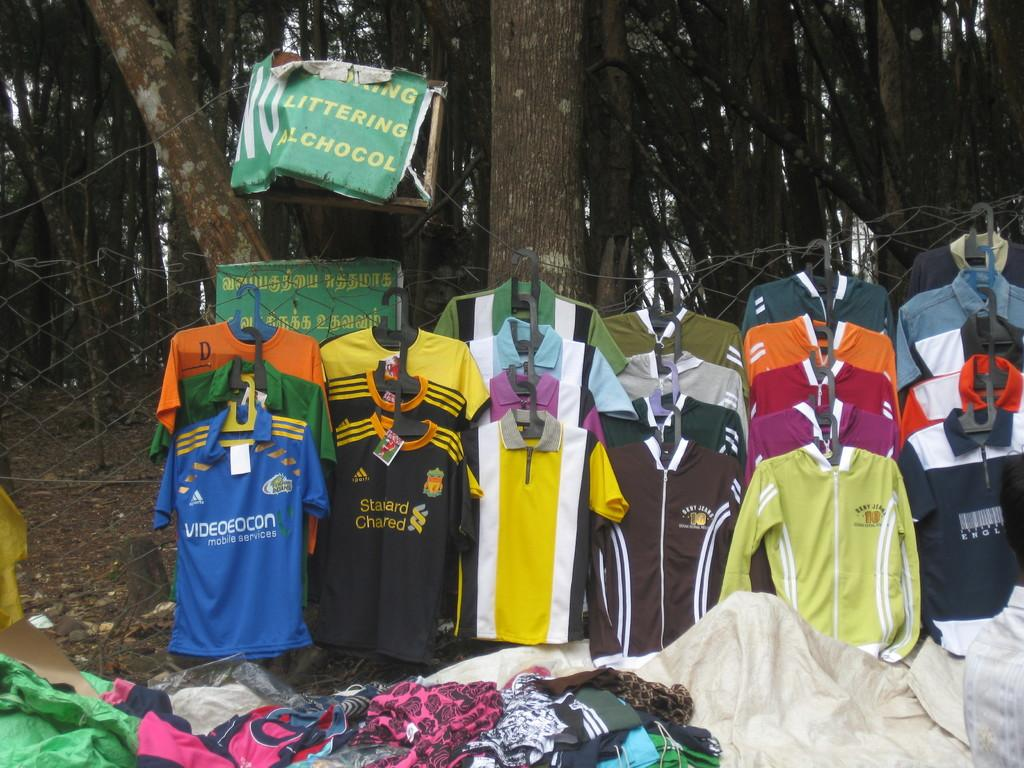<image>
Describe the image concisely. some clothing spread out in the woods with a sign above saying littering and alcohol prohibited. 